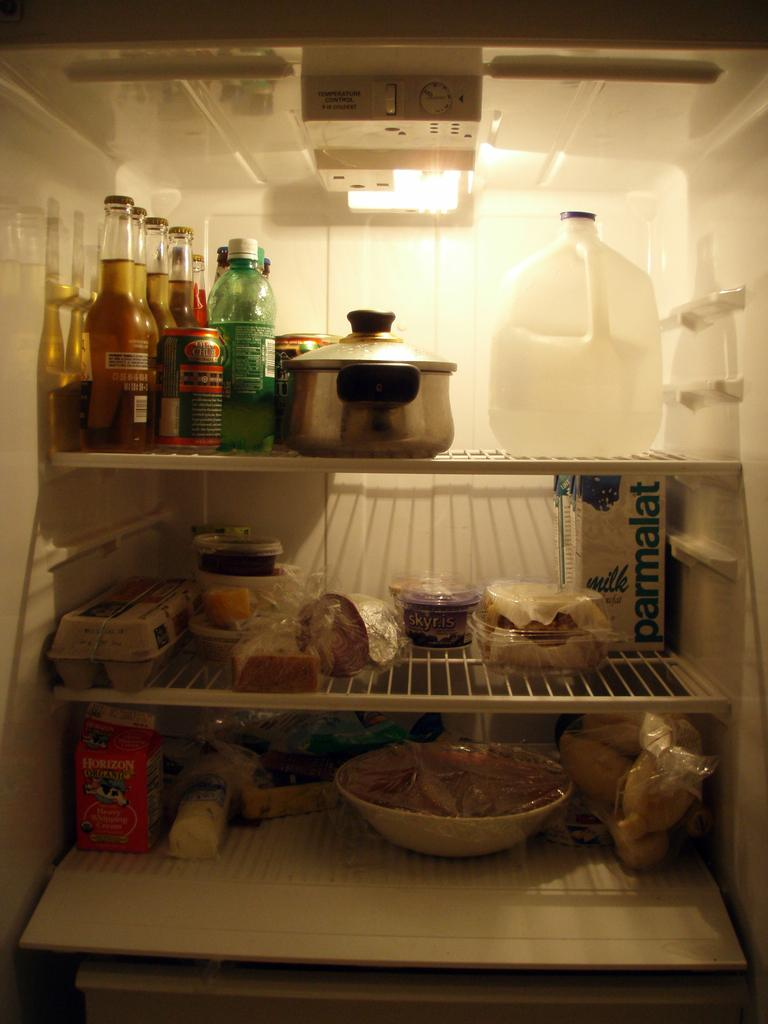<image>
Provide a brief description of the given image. an open fridge with items inside like Parmalat milk 